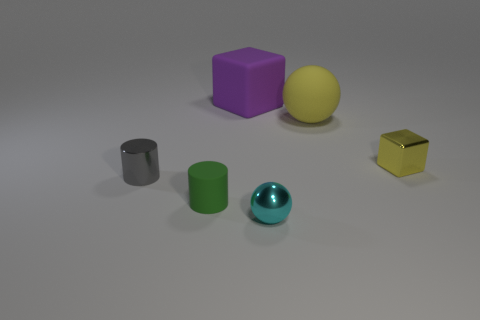Add 3 small matte cylinders. How many objects exist? 9 Add 3 metal cubes. How many metal cubes are left? 4 Add 5 tiny gray things. How many tiny gray things exist? 6 Subtract 0 yellow cylinders. How many objects are left? 6 Subtract all tiny green things. Subtract all cyan things. How many objects are left? 4 